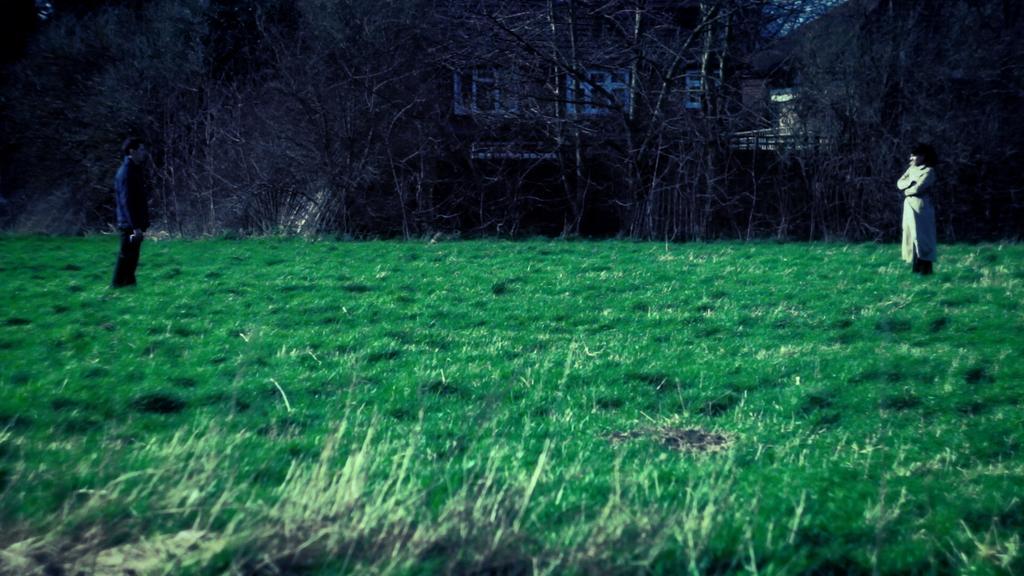Could you give a brief overview of what you see in this image? In the foreground of this image, there is grass. On the left, there is a man and on the right, there is a woman standing. In the background, there are trees and it seems like buildings behind it. 